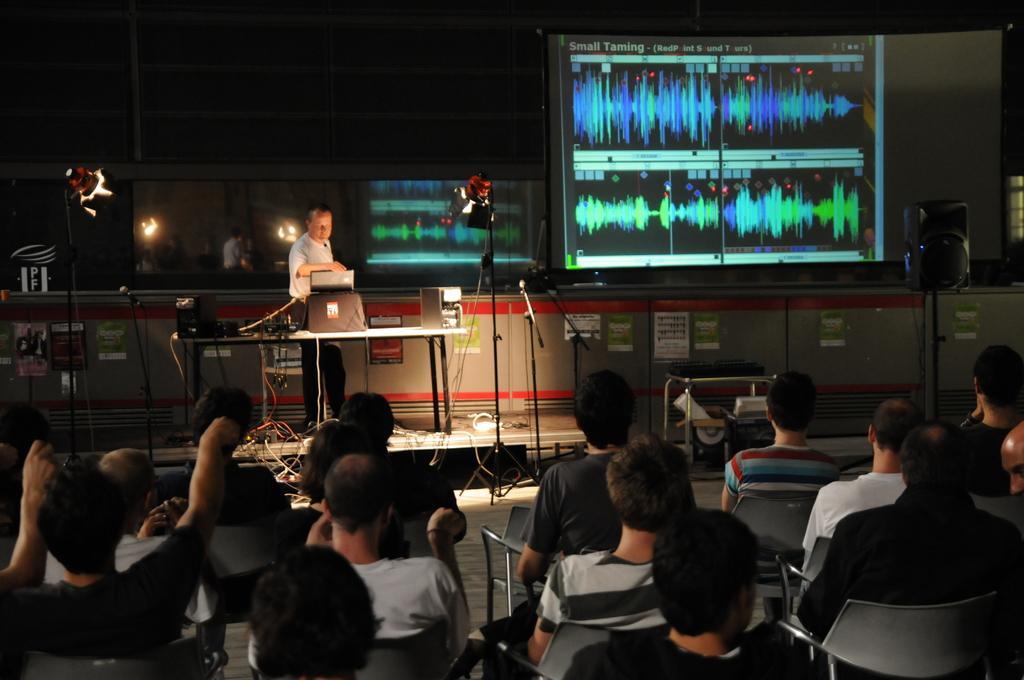In one or two sentences, can you explain what this image depicts? In this image there is a man standing on the stage. In front of him there is a table. On the table there are c. p. us,wires and a laptop. There are two lights on either side of him. On the right side top there is a screen. At the bottom there are spectators who are sitting in the chairs. 